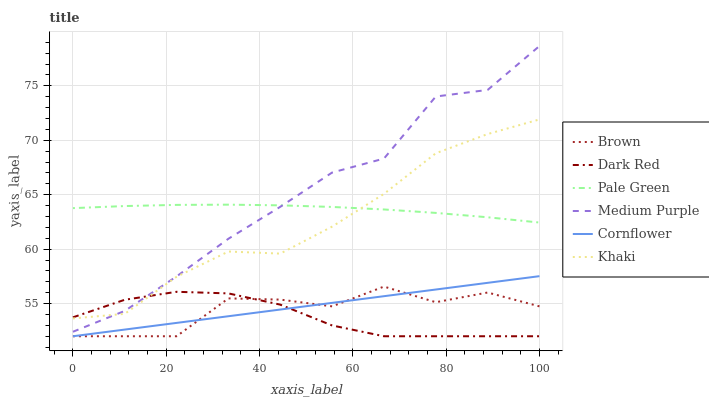Does Dark Red have the minimum area under the curve?
Answer yes or no. Yes. Does Medium Purple have the maximum area under the curve?
Answer yes or no. Yes. Does Khaki have the minimum area under the curve?
Answer yes or no. No. Does Khaki have the maximum area under the curve?
Answer yes or no. No. Is Cornflower the smoothest?
Answer yes or no. Yes. Is Brown the roughest?
Answer yes or no. Yes. Is Khaki the smoothest?
Answer yes or no. No. Is Khaki the roughest?
Answer yes or no. No. Does Brown have the lowest value?
Answer yes or no. Yes. Does Khaki have the lowest value?
Answer yes or no. No. Does Medium Purple have the highest value?
Answer yes or no. Yes. Does Khaki have the highest value?
Answer yes or no. No. Is Brown less than Khaki?
Answer yes or no. Yes. Is Khaki greater than Brown?
Answer yes or no. Yes. Does Cornflower intersect Dark Red?
Answer yes or no. Yes. Is Cornflower less than Dark Red?
Answer yes or no. No. Is Cornflower greater than Dark Red?
Answer yes or no. No. Does Brown intersect Khaki?
Answer yes or no. No. 